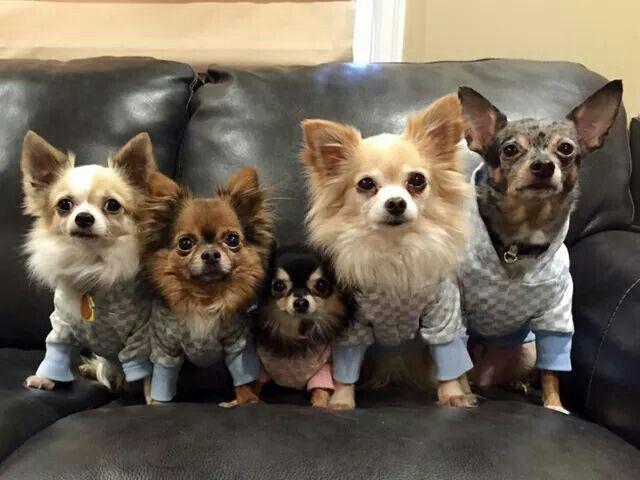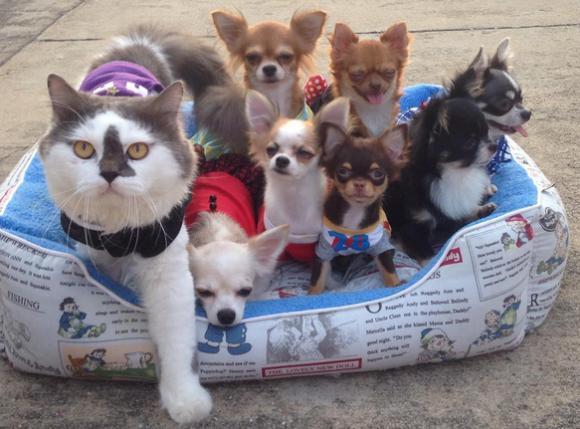The first image is the image on the left, the second image is the image on the right. Given the left and right images, does the statement "There are no more than three dogs" hold true? Answer yes or no. No. The first image is the image on the left, the second image is the image on the right. For the images shown, is this caption "Dogs in at least one image are dressed in clothing." true? Answer yes or no. Yes. 